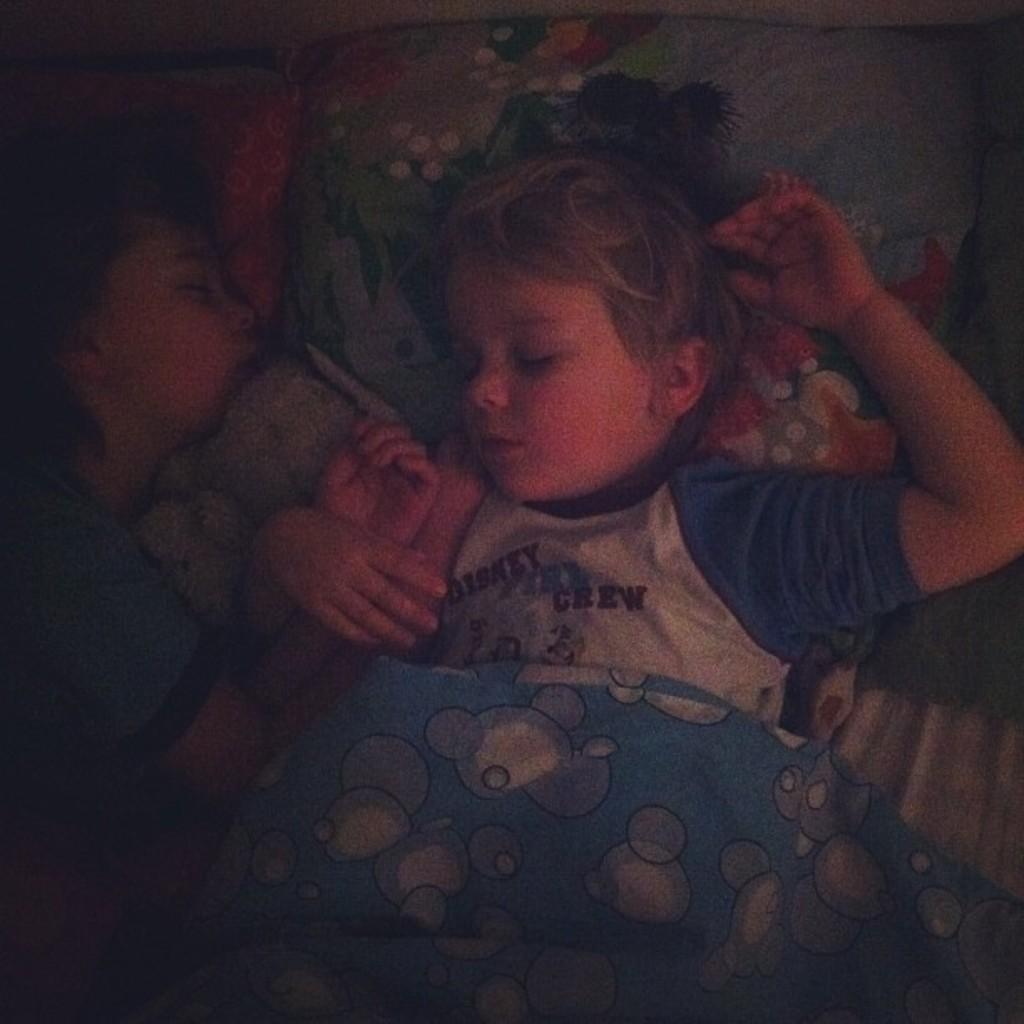Can you describe this image briefly? In the image two kids are sleeping on a bed. 